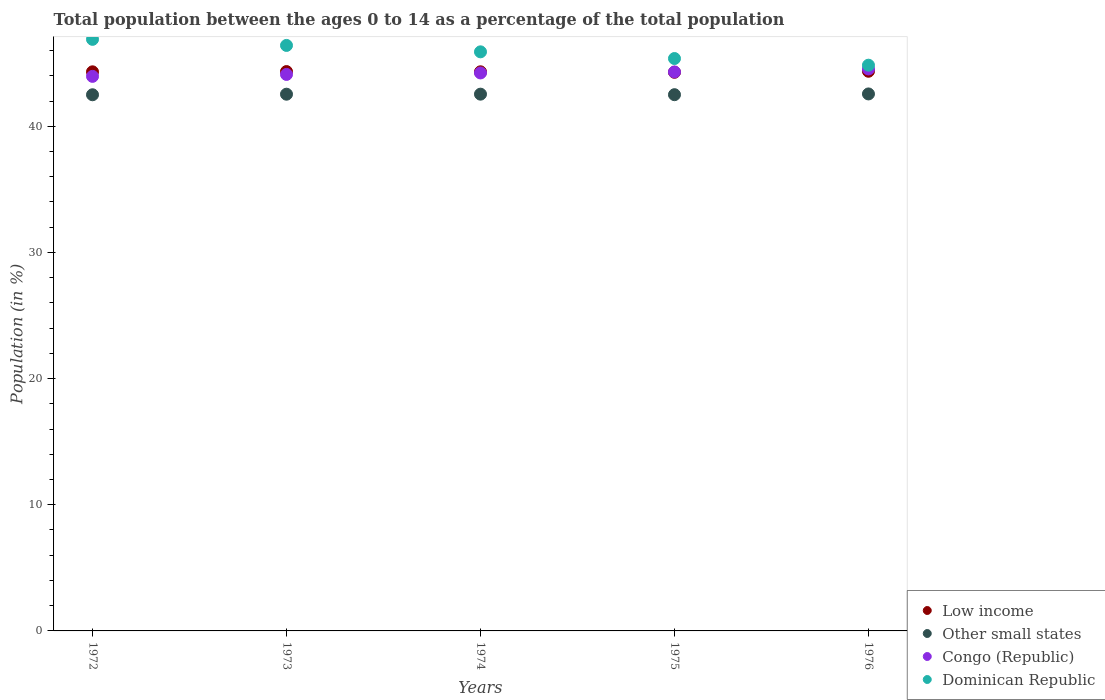How many different coloured dotlines are there?
Provide a short and direct response. 4. Is the number of dotlines equal to the number of legend labels?
Provide a succinct answer. Yes. What is the percentage of the population ages 0 to 14 in Congo (Republic) in 1976?
Offer a very short reply. 44.54. Across all years, what is the maximum percentage of the population ages 0 to 14 in Other small states?
Provide a succinct answer. 42.56. Across all years, what is the minimum percentage of the population ages 0 to 14 in Dominican Republic?
Give a very brief answer. 44.84. In which year was the percentage of the population ages 0 to 14 in Other small states maximum?
Keep it short and to the point. 1976. In which year was the percentage of the population ages 0 to 14 in Low income minimum?
Give a very brief answer. 1975. What is the total percentage of the population ages 0 to 14 in Congo (Republic) in the graph?
Provide a succinct answer. 221.13. What is the difference between the percentage of the population ages 0 to 14 in Low income in 1974 and that in 1976?
Offer a very short reply. -0.04. What is the difference between the percentage of the population ages 0 to 14 in Congo (Republic) in 1973 and the percentage of the population ages 0 to 14 in Low income in 1975?
Give a very brief answer. -0.17. What is the average percentage of the population ages 0 to 14 in Other small states per year?
Your answer should be compact. 42.53. In the year 1973, what is the difference between the percentage of the population ages 0 to 14 in Other small states and percentage of the population ages 0 to 14 in Congo (Republic)?
Offer a terse response. -1.57. In how many years, is the percentage of the population ages 0 to 14 in Dominican Republic greater than 44?
Your answer should be very brief. 5. What is the ratio of the percentage of the population ages 0 to 14 in Congo (Republic) in 1972 to that in 1974?
Offer a very short reply. 0.99. Is the difference between the percentage of the population ages 0 to 14 in Other small states in 1973 and 1974 greater than the difference between the percentage of the population ages 0 to 14 in Congo (Republic) in 1973 and 1974?
Make the answer very short. Yes. What is the difference between the highest and the second highest percentage of the population ages 0 to 14 in Low income?
Give a very brief answer. 0.02. What is the difference between the highest and the lowest percentage of the population ages 0 to 14 in Low income?
Your answer should be compact. 0.08. In how many years, is the percentage of the population ages 0 to 14 in Other small states greater than the average percentage of the population ages 0 to 14 in Other small states taken over all years?
Provide a short and direct response. 3. Is the sum of the percentage of the population ages 0 to 14 in Low income in 1974 and 1975 greater than the maximum percentage of the population ages 0 to 14 in Dominican Republic across all years?
Keep it short and to the point. Yes. Is it the case that in every year, the sum of the percentage of the population ages 0 to 14 in Congo (Republic) and percentage of the population ages 0 to 14 in Other small states  is greater than the sum of percentage of the population ages 0 to 14 in Low income and percentage of the population ages 0 to 14 in Dominican Republic?
Keep it short and to the point. No. Is it the case that in every year, the sum of the percentage of the population ages 0 to 14 in Dominican Republic and percentage of the population ages 0 to 14 in Low income  is greater than the percentage of the population ages 0 to 14 in Congo (Republic)?
Keep it short and to the point. Yes. How many dotlines are there?
Ensure brevity in your answer.  4. How many years are there in the graph?
Offer a terse response. 5. Are the values on the major ticks of Y-axis written in scientific E-notation?
Make the answer very short. No. Does the graph contain grids?
Ensure brevity in your answer.  No. Where does the legend appear in the graph?
Offer a very short reply. Bottom right. How many legend labels are there?
Your answer should be very brief. 4. How are the legend labels stacked?
Offer a very short reply. Vertical. What is the title of the graph?
Your answer should be compact. Total population between the ages 0 to 14 as a percentage of the total population. Does "Tanzania" appear as one of the legend labels in the graph?
Keep it short and to the point. No. What is the label or title of the Y-axis?
Keep it short and to the point. Population (in %). What is the Population (in %) of Low income in 1972?
Offer a terse response. 44.31. What is the Population (in %) of Other small states in 1972?
Provide a succinct answer. 42.5. What is the Population (in %) in Congo (Republic) in 1972?
Offer a terse response. 43.95. What is the Population (in %) of Dominican Republic in 1972?
Keep it short and to the point. 46.89. What is the Population (in %) of Low income in 1973?
Provide a short and direct response. 44.33. What is the Population (in %) of Other small states in 1973?
Give a very brief answer. 42.54. What is the Population (in %) of Congo (Republic) in 1973?
Offer a terse response. 44.11. What is the Population (in %) in Dominican Republic in 1973?
Ensure brevity in your answer.  46.41. What is the Population (in %) of Low income in 1974?
Your answer should be very brief. 44.31. What is the Population (in %) of Other small states in 1974?
Your answer should be very brief. 42.54. What is the Population (in %) of Congo (Republic) in 1974?
Your response must be concise. 44.22. What is the Population (in %) of Dominican Republic in 1974?
Give a very brief answer. 45.9. What is the Population (in %) in Low income in 1975?
Your response must be concise. 44.28. What is the Population (in %) in Other small states in 1975?
Make the answer very short. 42.5. What is the Population (in %) in Congo (Republic) in 1975?
Offer a terse response. 44.3. What is the Population (in %) in Dominican Republic in 1975?
Your response must be concise. 45.37. What is the Population (in %) of Low income in 1976?
Give a very brief answer. 44.36. What is the Population (in %) of Other small states in 1976?
Ensure brevity in your answer.  42.56. What is the Population (in %) of Congo (Republic) in 1976?
Your answer should be very brief. 44.54. What is the Population (in %) of Dominican Republic in 1976?
Ensure brevity in your answer.  44.84. Across all years, what is the maximum Population (in %) of Low income?
Give a very brief answer. 44.36. Across all years, what is the maximum Population (in %) of Other small states?
Offer a very short reply. 42.56. Across all years, what is the maximum Population (in %) in Congo (Republic)?
Make the answer very short. 44.54. Across all years, what is the maximum Population (in %) in Dominican Republic?
Your answer should be compact. 46.89. Across all years, what is the minimum Population (in %) in Low income?
Offer a very short reply. 44.28. Across all years, what is the minimum Population (in %) in Other small states?
Provide a succinct answer. 42.5. Across all years, what is the minimum Population (in %) of Congo (Republic)?
Your answer should be compact. 43.95. Across all years, what is the minimum Population (in %) of Dominican Republic?
Offer a terse response. 44.84. What is the total Population (in %) of Low income in the graph?
Give a very brief answer. 221.6. What is the total Population (in %) in Other small states in the graph?
Your answer should be very brief. 212.64. What is the total Population (in %) of Congo (Republic) in the graph?
Offer a very short reply. 221.13. What is the total Population (in %) of Dominican Republic in the graph?
Offer a very short reply. 229.4. What is the difference between the Population (in %) of Low income in 1972 and that in 1973?
Ensure brevity in your answer.  -0.02. What is the difference between the Population (in %) in Other small states in 1972 and that in 1973?
Ensure brevity in your answer.  -0.04. What is the difference between the Population (in %) in Congo (Republic) in 1972 and that in 1973?
Your answer should be very brief. -0.15. What is the difference between the Population (in %) of Dominican Republic in 1972 and that in 1973?
Offer a terse response. 0.48. What is the difference between the Population (in %) of Low income in 1972 and that in 1974?
Make the answer very short. -0. What is the difference between the Population (in %) in Other small states in 1972 and that in 1974?
Keep it short and to the point. -0.05. What is the difference between the Population (in %) in Congo (Republic) in 1972 and that in 1974?
Your response must be concise. -0.27. What is the difference between the Population (in %) in Dominican Republic in 1972 and that in 1974?
Ensure brevity in your answer.  0.99. What is the difference between the Population (in %) in Low income in 1972 and that in 1975?
Provide a short and direct response. 0.04. What is the difference between the Population (in %) of Other small states in 1972 and that in 1975?
Give a very brief answer. -0.01. What is the difference between the Population (in %) in Congo (Republic) in 1972 and that in 1975?
Ensure brevity in your answer.  -0.35. What is the difference between the Population (in %) of Dominican Republic in 1972 and that in 1975?
Offer a terse response. 1.52. What is the difference between the Population (in %) in Low income in 1972 and that in 1976?
Provide a short and direct response. -0.04. What is the difference between the Population (in %) in Other small states in 1972 and that in 1976?
Your answer should be compact. -0.07. What is the difference between the Population (in %) in Congo (Republic) in 1972 and that in 1976?
Your answer should be very brief. -0.59. What is the difference between the Population (in %) in Dominican Republic in 1972 and that in 1976?
Give a very brief answer. 2.05. What is the difference between the Population (in %) in Low income in 1973 and that in 1974?
Your answer should be very brief. 0.02. What is the difference between the Population (in %) of Other small states in 1973 and that in 1974?
Offer a terse response. -0. What is the difference between the Population (in %) of Congo (Republic) in 1973 and that in 1974?
Provide a succinct answer. -0.12. What is the difference between the Population (in %) of Dominican Republic in 1973 and that in 1974?
Provide a succinct answer. 0.51. What is the difference between the Population (in %) in Low income in 1973 and that in 1975?
Keep it short and to the point. 0.06. What is the difference between the Population (in %) in Other small states in 1973 and that in 1975?
Offer a terse response. 0.04. What is the difference between the Population (in %) in Congo (Republic) in 1973 and that in 1975?
Make the answer very short. -0.2. What is the difference between the Population (in %) of Low income in 1973 and that in 1976?
Provide a succinct answer. -0.02. What is the difference between the Population (in %) in Other small states in 1973 and that in 1976?
Provide a succinct answer. -0.02. What is the difference between the Population (in %) of Congo (Republic) in 1973 and that in 1976?
Keep it short and to the point. -0.43. What is the difference between the Population (in %) in Dominican Republic in 1973 and that in 1976?
Your response must be concise. 1.57. What is the difference between the Population (in %) in Low income in 1974 and that in 1975?
Keep it short and to the point. 0.04. What is the difference between the Population (in %) of Other small states in 1974 and that in 1975?
Keep it short and to the point. 0.04. What is the difference between the Population (in %) of Congo (Republic) in 1974 and that in 1975?
Your response must be concise. -0.08. What is the difference between the Population (in %) of Dominican Republic in 1974 and that in 1975?
Offer a terse response. 0.53. What is the difference between the Population (in %) of Low income in 1974 and that in 1976?
Offer a very short reply. -0.04. What is the difference between the Population (in %) of Other small states in 1974 and that in 1976?
Your response must be concise. -0.02. What is the difference between the Population (in %) of Congo (Republic) in 1974 and that in 1976?
Ensure brevity in your answer.  -0.32. What is the difference between the Population (in %) of Dominican Republic in 1974 and that in 1976?
Ensure brevity in your answer.  1.06. What is the difference between the Population (in %) in Low income in 1975 and that in 1976?
Give a very brief answer. -0.08. What is the difference between the Population (in %) in Other small states in 1975 and that in 1976?
Your answer should be very brief. -0.06. What is the difference between the Population (in %) in Congo (Republic) in 1975 and that in 1976?
Ensure brevity in your answer.  -0.24. What is the difference between the Population (in %) in Dominican Republic in 1975 and that in 1976?
Ensure brevity in your answer.  0.53. What is the difference between the Population (in %) in Low income in 1972 and the Population (in %) in Other small states in 1973?
Offer a very short reply. 1.77. What is the difference between the Population (in %) of Low income in 1972 and the Population (in %) of Congo (Republic) in 1973?
Ensure brevity in your answer.  0.21. What is the difference between the Population (in %) of Low income in 1972 and the Population (in %) of Dominican Republic in 1973?
Offer a terse response. -2.09. What is the difference between the Population (in %) in Other small states in 1972 and the Population (in %) in Congo (Republic) in 1973?
Ensure brevity in your answer.  -1.61. What is the difference between the Population (in %) in Other small states in 1972 and the Population (in %) in Dominican Republic in 1973?
Keep it short and to the point. -3.91. What is the difference between the Population (in %) in Congo (Republic) in 1972 and the Population (in %) in Dominican Republic in 1973?
Your answer should be compact. -2.45. What is the difference between the Population (in %) in Low income in 1972 and the Population (in %) in Other small states in 1974?
Provide a succinct answer. 1.77. What is the difference between the Population (in %) of Low income in 1972 and the Population (in %) of Congo (Republic) in 1974?
Make the answer very short. 0.09. What is the difference between the Population (in %) of Low income in 1972 and the Population (in %) of Dominican Republic in 1974?
Keep it short and to the point. -1.58. What is the difference between the Population (in %) in Other small states in 1972 and the Population (in %) in Congo (Republic) in 1974?
Keep it short and to the point. -1.73. What is the difference between the Population (in %) of Other small states in 1972 and the Population (in %) of Dominican Republic in 1974?
Provide a succinct answer. -3.4. What is the difference between the Population (in %) in Congo (Republic) in 1972 and the Population (in %) in Dominican Republic in 1974?
Provide a short and direct response. -1.94. What is the difference between the Population (in %) in Low income in 1972 and the Population (in %) in Other small states in 1975?
Provide a succinct answer. 1.81. What is the difference between the Population (in %) in Low income in 1972 and the Population (in %) in Congo (Republic) in 1975?
Your response must be concise. 0.01. What is the difference between the Population (in %) of Low income in 1972 and the Population (in %) of Dominican Republic in 1975?
Your answer should be compact. -1.05. What is the difference between the Population (in %) of Other small states in 1972 and the Population (in %) of Congo (Republic) in 1975?
Make the answer very short. -1.81. What is the difference between the Population (in %) in Other small states in 1972 and the Population (in %) in Dominican Republic in 1975?
Offer a terse response. -2.87. What is the difference between the Population (in %) in Congo (Republic) in 1972 and the Population (in %) in Dominican Republic in 1975?
Provide a short and direct response. -1.41. What is the difference between the Population (in %) in Low income in 1972 and the Population (in %) in Other small states in 1976?
Offer a very short reply. 1.75. What is the difference between the Population (in %) of Low income in 1972 and the Population (in %) of Congo (Republic) in 1976?
Your answer should be compact. -0.23. What is the difference between the Population (in %) of Low income in 1972 and the Population (in %) of Dominican Republic in 1976?
Provide a short and direct response. -0.53. What is the difference between the Population (in %) in Other small states in 1972 and the Population (in %) in Congo (Republic) in 1976?
Keep it short and to the point. -2.04. What is the difference between the Population (in %) in Other small states in 1972 and the Population (in %) in Dominican Republic in 1976?
Give a very brief answer. -2.34. What is the difference between the Population (in %) of Congo (Republic) in 1972 and the Population (in %) of Dominican Republic in 1976?
Provide a short and direct response. -0.89. What is the difference between the Population (in %) of Low income in 1973 and the Population (in %) of Other small states in 1974?
Your answer should be compact. 1.79. What is the difference between the Population (in %) in Low income in 1973 and the Population (in %) in Congo (Republic) in 1974?
Provide a short and direct response. 0.11. What is the difference between the Population (in %) in Low income in 1973 and the Population (in %) in Dominican Republic in 1974?
Provide a short and direct response. -1.56. What is the difference between the Population (in %) in Other small states in 1973 and the Population (in %) in Congo (Republic) in 1974?
Your answer should be very brief. -1.68. What is the difference between the Population (in %) of Other small states in 1973 and the Population (in %) of Dominican Republic in 1974?
Keep it short and to the point. -3.36. What is the difference between the Population (in %) of Congo (Republic) in 1973 and the Population (in %) of Dominican Republic in 1974?
Provide a succinct answer. -1.79. What is the difference between the Population (in %) of Low income in 1973 and the Population (in %) of Other small states in 1975?
Offer a very short reply. 1.83. What is the difference between the Population (in %) of Low income in 1973 and the Population (in %) of Congo (Republic) in 1975?
Provide a short and direct response. 0.03. What is the difference between the Population (in %) in Low income in 1973 and the Population (in %) in Dominican Republic in 1975?
Your answer should be very brief. -1.03. What is the difference between the Population (in %) of Other small states in 1973 and the Population (in %) of Congo (Republic) in 1975?
Provide a short and direct response. -1.76. What is the difference between the Population (in %) of Other small states in 1973 and the Population (in %) of Dominican Republic in 1975?
Provide a succinct answer. -2.83. What is the difference between the Population (in %) of Congo (Republic) in 1973 and the Population (in %) of Dominican Republic in 1975?
Give a very brief answer. -1.26. What is the difference between the Population (in %) of Low income in 1973 and the Population (in %) of Other small states in 1976?
Your response must be concise. 1.77. What is the difference between the Population (in %) in Low income in 1973 and the Population (in %) in Congo (Republic) in 1976?
Ensure brevity in your answer.  -0.21. What is the difference between the Population (in %) of Low income in 1973 and the Population (in %) of Dominican Republic in 1976?
Keep it short and to the point. -0.51. What is the difference between the Population (in %) of Other small states in 1973 and the Population (in %) of Congo (Republic) in 1976?
Your answer should be compact. -2. What is the difference between the Population (in %) in Other small states in 1973 and the Population (in %) in Dominican Republic in 1976?
Your answer should be compact. -2.3. What is the difference between the Population (in %) in Congo (Republic) in 1973 and the Population (in %) in Dominican Republic in 1976?
Keep it short and to the point. -0.73. What is the difference between the Population (in %) in Low income in 1974 and the Population (in %) in Other small states in 1975?
Your answer should be very brief. 1.81. What is the difference between the Population (in %) in Low income in 1974 and the Population (in %) in Congo (Republic) in 1975?
Your answer should be compact. 0.01. What is the difference between the Population (in %) in Low income in 1974 and the Population (in %) in Dominican Republic in 1975?
Make the answer very short. -1.05. What is the difference between the Population (in %) in Other small states in 1974 and the Population (in %) in Congo (Republic) in 1975?
Give a very brief answer. -1.76. What is the difference between the Population (in %) in Other small states in 1974 and the Population (in %) in Dominican Republic in 1975?
Provide a short and direct response. -2.82. What is the difference between the Population (in %) of Congo (Republic) in 1974 and the Population (in %) of Dominican Republic in 1975?
Your answer should be very brief. -1.14. What is the difference between the Population (in %) in Low income in 1974 and the Population (in %) in Other small states in 1976?
Offer a terse response. 1.75. What is the difference between the Population (in %) in Low income in 1974 and the Population (in %) in Congo (Republic) in 1976?
Your answer should be very brief. -0.22. What is the difference between the Population (in %) in Low income in 1974 and the Population (in %) in Dominican Republic in 1976?
Offer a very short reply. -0.52. What is the difference between the Population (in %) in Other small states in 1974 and the Population (in %) in Congo (Republic) in 1976?
Your answer should be compact. -2. What is the difference between the Population (in %) of Other small states in 1974 and the Population (in %) of Dominican Republic in 1976?
Offer a terse response. -2.3. What is the difference between the Population (in %) in Congo (Republic) in 1974 and the Population (in %) in Dominican Republic in 1976?
Your answer should be compact. -0.61. What is the difference between the Population (in %) in Low income in 1975 and the Population (in %) in Other small states in 1976?
Your answer should be very brief. 1.72. What is the difference between the Population (in %) of Low income in 1975 and the Population (in %) of Congo (Republic) in 1976?
Keep it short and to the point. -0.26. What is the difference between the Population (in %) of Low income in 1975 and the Population (in %) of Dominican Republic in 1976?
Offer a very short reply. -0.56. What is the difference between the Population (in %) in Other small states in 1975 and the Population (in %) in Congo (Republic) in 1976?
Your response must be concise. -2.04. What is the difference between the Population (in %) in Other small states in 1975 and the Population (in %) in Dominican Republic in 1976?
Your response must be concise. -2.34. What is the difference between the Population (in %) in Congo (Republic) in 1975 and the Population (in %) in Dominican Republic in 1976?
Your response must be concise. -0.53. What is the average Population (in %) in Low income per year?
Your answer should be very brief. 44.32. What is the average Population (in %) in Other small states per year?
Make the answer very short. 42.53. What is the average Population (in %) in Congo (Republic) per year?
Your answer should be compact. 44.23. What is the average Population (in %) of Dominican Republic per year?
Give a very brief answer. 45.88. In the year 1972, what is the difference between the Population (in %) of Low income and Population (in %) of Other small states?
Keep it short and to the point. 1.82. In the year 1972, what is the difference between the Population (in %) in Low income and Population (in %) in Congo (Republic)?
Make the answer very short. 0.36. In the year 1972, what is the difference between the Population (in %) of Low income and Population (in %) of Dominican Republic?
Provide a short and direct response. -2.57. In the year 1972, what is the difference between the Population (in %) of Other small states and Population (in %) of Congo (Republic)?
Your answer should be compact. -1.46. In the year 1972, what is the difference between the Population (in %) of Other small states and Population (in %) of Dominican Republic?
Provide a short and direct response. -4.39. In the year 1972, what is the difference between the Population (in %) of Congo (Republic) and Population (in %) of Dominican Republic?
Provide a short and direct response. -2.93. In the year 1973, what is the difference between the Population (in %) in Low income and Population (in %) in Other small states?
Provide a short and direct response. 1.79. In the year 1973, what is the difference between the Population (in %) in Low income and Population (in %) in Congo (Republic)?
Ensure brevity in your answer.  0.23. In the year 1973, what is the difference between the Population (in %) in Low income and Population (in %) in Dominican Republic?
Keep it short and to the point. -2.07. In the year 1973, what is the difference between the Population (in %) in Other small states and Population (in %) in Congo (Republic)?
Ensure brevity in your answer.  -1.57. In the year 1973, what is the difference between the Population (in %) of Other small states and Population (in %) of Dominican Republic?
Your response must be concise. -3.87. In the year 1973, what is the difference between the Population (in %) of Congo (Republic) and Population (in %) of Dominican Republic?
Give a very brief answer. -2.3. In the year 1974, what is the difference between the Population (in %) of Low income and Population (in %) of Other small states?
Provide a succinct answer. 1.77. In the year 1974, what is the difference between the Population (in %) in Low income and Population (in %) in Congo (Republic)?
Provide a short and direct response. 0.09. In the year 1974, what is the difference between the Population (in %) of Low income and Population (in %) of Dominican Republic?
Give a very brief answer. -1.58. In the year 1974, what is the difference between the Population (in %) in Other small states and Population (in %) in Congo (Republic)?
Provide a short and direct response. -1.68. In the year 1974, what is the difference between the Population (in %) of Other small states and Population (in %) of Dominican Republic?
Provide a short and direct response. -3.35. In the year 1974, what is the difference between the Population (in %) in Congo (Republic) and Population (in %) in Dominican Republic?
Ensure brevity in your answer.  -1.67. In the year 1975, what is the difference between the Population (in %) of Low income and Population (in %) of Other small states?
Ensure brevity in your answer.  1.77. In the year 1975, what is the difference between the Population (in %) in Low income and Population (in %) in Congo (Republic)?
Ensure brevity in your answer.  -0.03. In the year 1975, what is the difference between the Population (in %) of Low income and Population (in %) of Dominican Republic?
Keep it short and to the point. -1.09. In the year 1975, what is the difference between the Population (in %) of Other small states and Population (in %) of Congo (Republic)?
Keep it short and to the point. -1.8. In the year 1975, what is the difference between the Population (in %) of Other small states and Population (in %) of Dominican Republic?
Make the answer very short. -2.87. In the year 1975, what is the difference between the Population (in %) of Congo (Republic) and Population (in %) of Dominican Republic?
Ensure brevity in your answer.  -1.06. In the year 1976, what is the difference between the Population (in %) of Low income and Population (in %) of Other small states?
Give a very brief answer. 1.8. In the year 1976, what is the difference between the Population (in %) of Low income and Population (in %) of Congo (Republic)?
Offer a terse response. -0.18. In the year 1976, what is the difference between the Population (in %) in Low income and Population (in %) in Dominican Republic?
Give a very brief answer. -0.48. In the year 1976, what is the difference between the Population (in %) in Other small states and Population (in %) in Congo (Republic)?
Ensure brevity in your answer.  -1.98. In the year 1976, what is the difference between the Population (in %) in Other small states and Population (in %) in Dominican Republic?
Provide a succinct answer. -2.28. In the year 1976, what is the difference between the Population (in %) of Congo (Republic) and Population (in %) of Dominican Republic?
Provide a succinct answer. -0.3. What is the ratio of the Population (in %) in Low income in 1972 to that in 1973?
Keep it short and to the point. 1. What is the ratio of the Population (in %) of Congo (Republic) in 1972 to that in 1973?
Ensure brevity in your answer.  1. What is the ratio of the Population (in %) of Dominican Republic in 1972 to that in 1973?
Make the answer very short. 1.01. What is the ratio of the Population (in %) of Low income in 1972 to that in 1974?
Give a very brief answer. 1. What is the ratio of the Population (in %) in Other small states in 1972 to that in 1974?
Provide a short and direct response. 1. What is the ratio of the Population (in %) of Dominican Republic in 1972 to that in 1974?
Your answer should be compact. 1.02. What is the ratio of the Population (in %) in Other small states in 1972 to that in 1975?
Your response must be concise. 1. What is the ratio of the Population (in %) of Congo (Republic) in 1972 to that in 1975?
Make the answer very short. 0.99. What is the ratio of the Population (in %) in Dominican Republic in 1972 to that in 1975?
Provide a short and direct response. 1.03. What is the ratio of the Population (in %) in Low income in 1972 to that in 1976?
Offer a very short reply. 1. What is the ratio of the Population (in %) of Congo (Republic) in 1972 to that in 1976?
Your answer should be very brief. 0.99. What is the ratio of the Population (in %) in Dominican Republic in 1972 to that in 1976?
Your answer should be very brief. 1.05. What is the ratio of the Population (in %) in Congo (Republic) in 1973 to that in 1974?
Your answer should be very brief. 1. What is the ratio of the Population (in %) in Dominican Republic in 1973 to that in 1974?
Your response must be concise. 1.01. What is the ratio of the Population (in %) of Low income in 1973 to that in 1975?
Your answer should be very brief. 1. What is the ratio of the Population (in %) in Congo (Republic) in 1973 to that in 1975?
Offer a very short reply. 1. What is the ratio of the Population (in %) in Dominican Republic in 1973 to that in 1975?
Give a very brief answer. 1.02. What is the ratio of the Population (in %) of Other small states in 1973 to that in 1976?
Your answer should be compact. 1. What is the ratio of the Population (in %) of Congo (Republic) in 1973 to that in 1976?
Keep it short and to the point. 0.99. What is the ratio of the Population (in %) of Dominican Republic in 1973 to that in 1976?
Give a very brief answer. 1.03. What is the ratio of the Population (in %) of Low income in 1974 to that in 1975?
Ensure brevity in your answer.  1. What is the ratio of the Population (in %) in Other small states in 1974 to that in 1975?
Your answer should be compact. 1. What is the ratio of the Population (in %) of Congo (Republic) in 1974 to that in 1975?
Give a very brief answer. 1. What is the ratio of the Population (in %) of Dominican Republic in 1974 to that in 1975?
Provide a succinct answer. 1.01. What is the ratio of the Population (in %) in Low income in 1974 to that in 1976?
Provide a succinct answer. 1. What is the ratio of the Population (in %) in Other small states in 1974 to that in 1976?
Provide a short and direct response. 1. What is the ratio of the Population (in %) in Congo (Republic) in 1974 to that in 1976?
Offer a terse response. 0.99. What is the ratio of the Population (in %) in Dominican Republic in 1974 to that in 1976?
Offer a terse response. 1.02. What is the ratio of the Population (in %) in Other small states in 1975 to that in 1976?
Offer a terse response. 1. What is the ratio of the Population (in %) of Dominican Republic in 1975 to that in 1976?
Your answer should be compact. 1.01. What is the difference between the highest and the second highest Population (in %) in Low income?
Your response must be concise. 0.02. What is the difference between the highest and the second highest Population (in %) of Other small states?
Your answer should be compact. 0.02. What is the difference between the highest and the second highest Population (in %) of Congo (Republic)?
Your response must be concise. 0.24. What is the difference between the highest and the second highest Population (in %) in Dominican Republic?
Your response must be concise. 0.48. What is the difference between the highest and the lowest Population (in %) in Low income?
Offer a terse response. 0.08. What is the difference between the highest and the lowest Population (in %) of Other small states?
Provide a succinct answer. 0.07. What is the difference between the highest and the lowest Population (in %) of Congo (Republic)?
Provide a short and direct response. 0.59. What is the difference between the highest and the lowest Population (in %) of Dominican Republic?
Provide a succinct answer. 2.05. 